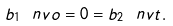Convert formula to latex. <formula><loc_0><loc_0><loc_500><loc_500>b _ { 1 } \ n v o = 0 = b _ { 2 } \ n v t .</formula> 